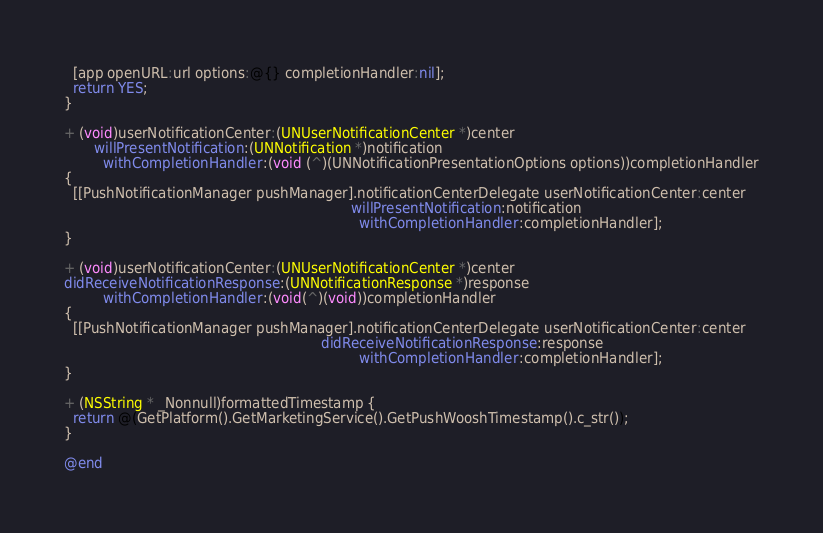<code> <loc_0><loc_0><loc_500><loc_500><_ObjectiveC_>  [app openURL:url options:@{} completionHandler:nil];
  return YES;
}

+ (void)userNotificationCenter:(UNUserNotificationCenter *)center
       willPresentNotification:(UNNotification *)notification
         withCompletionHandler:(void (^)(UNNotificationPresentationOptions options))completionHandler
{
  [[PushNotificationManager pushManager].notificationCenterDelegate userNotificationCenter:center
                                                                   willPresentNotification:notification
                                                                     withCompletionHandler:completionHandler];
}

+ (void)userNotificationCenter:(UNUserNotificationCenter *)center
didReceiveNotificationResponse:(UNNotificationResponse *)response
         withCompletionHandler:(void(^)(void))completionHandler
{
  [[PushNotificationManager pushManager].notificationCenterDelegate userNotificationCenter:center
                                                            didReceiveNotificationResponse:response
                                                                     withCompletionHandler:completionHandler];
}

+ (NSString * _Nonnull)formattedTimestamp {
  return @(GetPlatform().GetMarketingService().GetPushWooshTimestamp().c_str());
}

@end
</code> 